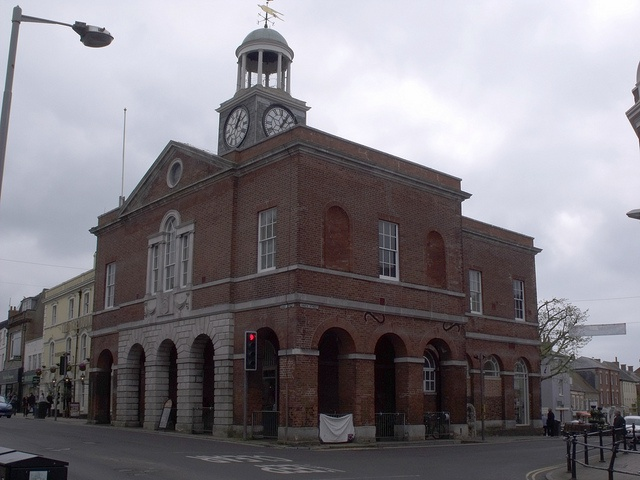Describe the objects in this image and their specific colors. I can see clock in lavender, gray, and black tones, clock in lavender, gray, and black tones, traffic light in lavender, black, gray, and maroon tones, car in lavender, gray, darkgray, and black tones, and people in gray, black, and lavender tones in this image. 